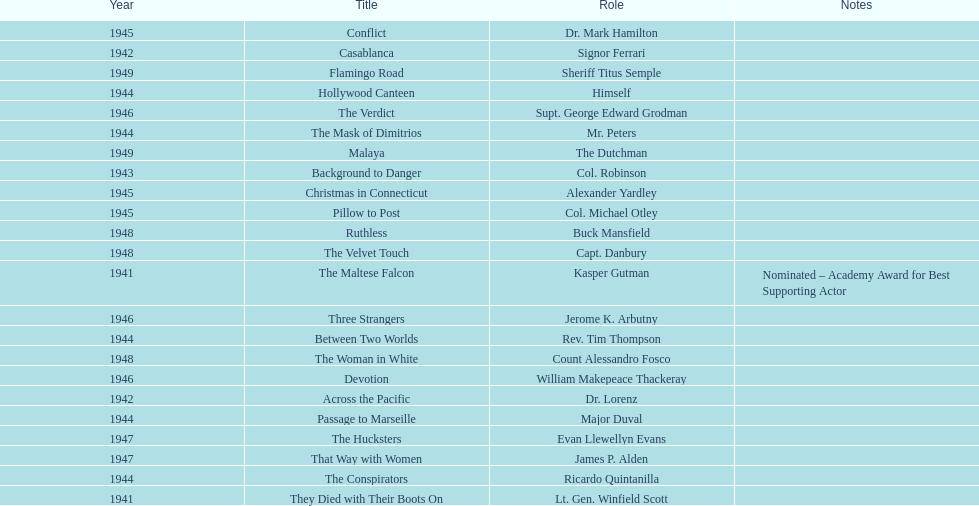How many movies has he been from 1941-1949. 23. 